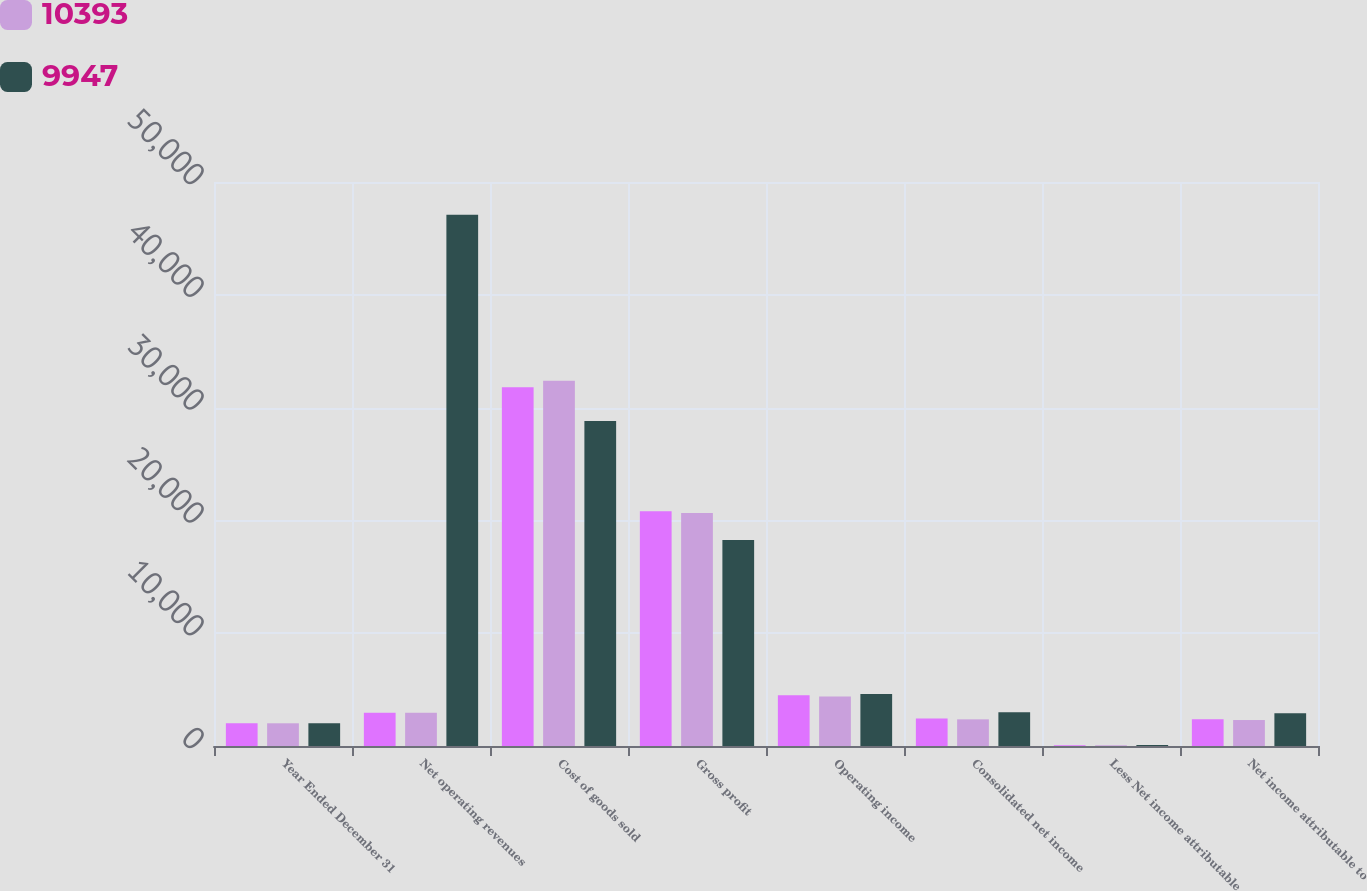Convert chart. <chart><loc_0><loc_0><loc_500><loc_500><stacked_bar_chart><ecel><fcel>Year Ended December 31<fcel>Net operating revenues<fcel>Cost of goods sold<fcel>Gross profit<fcel>Operating income<fcel>Consolidated net income<fcel>Less Net income attributable<fcel>Net income attributable to<nl><fcel>nan<fcel>2014<fcel>2948.5<fcel>31810<fcel>20817<fcel>4489<fcel>2440<fcel>74<fcel>2366<nl><fcel>10393<fcel>2013<fcel>2948.5<fcel>32377<fcel>20661<fcel>4380<fcel>2364<fcel>62<fcel>2302<nl><fcel>9947<fcel>2012<fcel>47087<fcel>28821<fcel>18266<fcel>4605<fcel>2993<fcel>89<fcel>2904<nl></chart> 